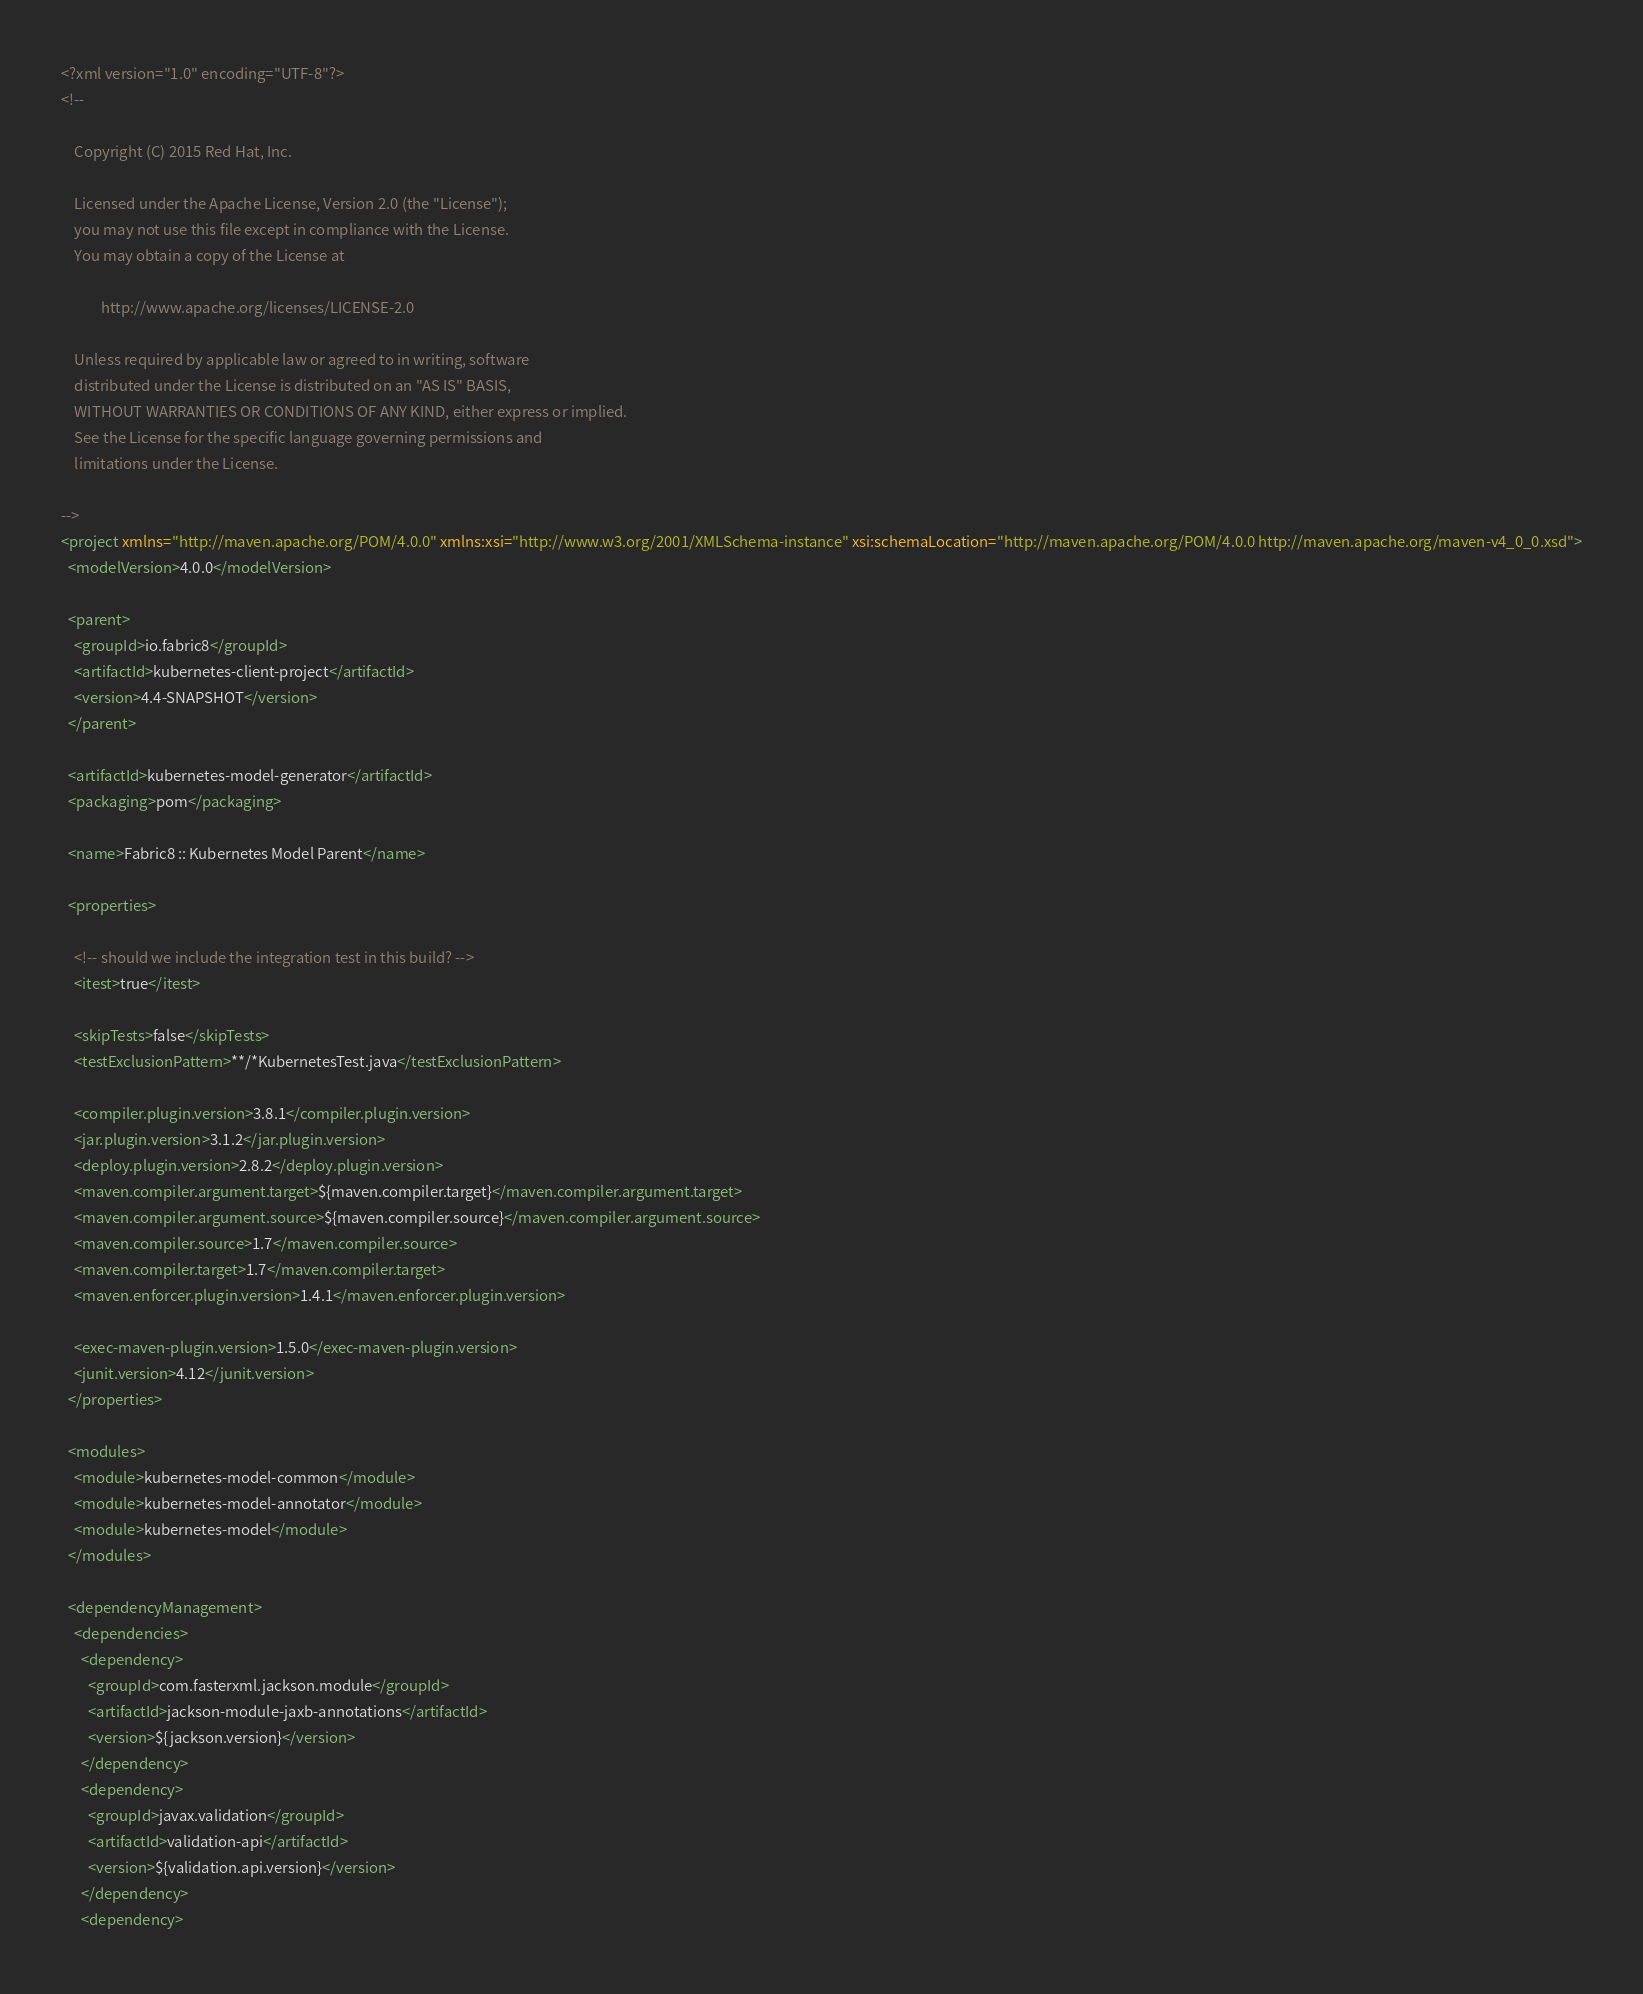Convert code to text. <code><loc_0><loc_0><loc_500><loc_500><_XML_><?xml version="1.0" encoding="UTF-8"?>
<!--

    Copyright (C) 2015 Red Hat, Inc.

    Licensed under the Apache License, Version 2.0 (the "License");
    you may not use this file except in compliance with the License.
    You may obtain a copy of the License at

            http://www.apache.org/licenses/LICENSE-2.0

    Unless required by applicable law or agreed to in writing, software
    distributed under the License is distributed on an "AS IS" BASIS,
    WITHOUT WARRANTIES OR CONDITIONS OF ANY KIND, either express or implied.
    See the License for the specific language governing permissions and
    limitations under the License.

-->
<project xmlns="http://maven.apache.org/POM/4.0.0" xmlns:xsi="http://www.w3.org/2001/XMLSchema-instance" xsi:schemaLocation="http://maven.apache.org/POM/4.0.0 http://maven.apache.org/maven-v4_0_0.xsd">
  <modelVersion>4.0.0</modelVersion>

  <parent>
    <groupId>io.fabric8</groupId>
    <artifactId>kubernetes-client-project</artifactId>
    <version>4.4-SNAPSHOT</version>
  </parent>

  <artifactId>kubernetes-model-generator</artifactId>
  <packaging>pom</packaging>

  <name>Fabric8 :: Kubernetes Model Parent</name>

  <properties>

    <!-- should we include the integration test in this build? -->
    <itest>true</itest>

    <skipTests>false</skipTests>
    <testExclusionPattern>**/*KubernetesTest.java</testExclusionPattern>

    <compiler.plugin.version>3.8.1</compiler.plugin.version>
    <jar.plugin.version>3.1.2</jar.plugin.version>
    <deploy.plugin.version>2.8.2</deploy.plugin.version>
    <maven.compiler.argument.target>${maven.compiler.target}</maven.compiler.argument.target>
    <maven.compiler.argument.source>${maven.compiler.source}</maven.compiler.argument.source>
    <maven.compiler.source>1.7</maven.compiler.source>
    <maven.compiler.target>1.7</maven.compiler.target>
    <maven.enforcer.plugin.version>1.4.1</maven.enforcer.plugin.version>

    <exec-maven-plugin.version>1.5.0</exec-maven-plugin.version>
    <junit.version>4.12</junit.version>
  </properties>

  <modules>
    <module>kubernetes-model-common</module>
    <module>kubernetes-model-annotator</module>
    <module>kubernetes-model</module>
  </modules>

  <dependencyManagement>
    <dependencies>
      <dependency>
        <groupId>com.fasterxml.jackson.module</groupId>
        <artifactId>jackson-module-jaxb-annotations</artifactId>
        <version>${jackson.version}</version>
      </dependency>
      <dependency>
        <groupId>javax.validation</groupId>
        <artifactId>validation-api</artifactId>
        <version>${validation.api.version}</version>
      </dependency>
      <dependency></code> 